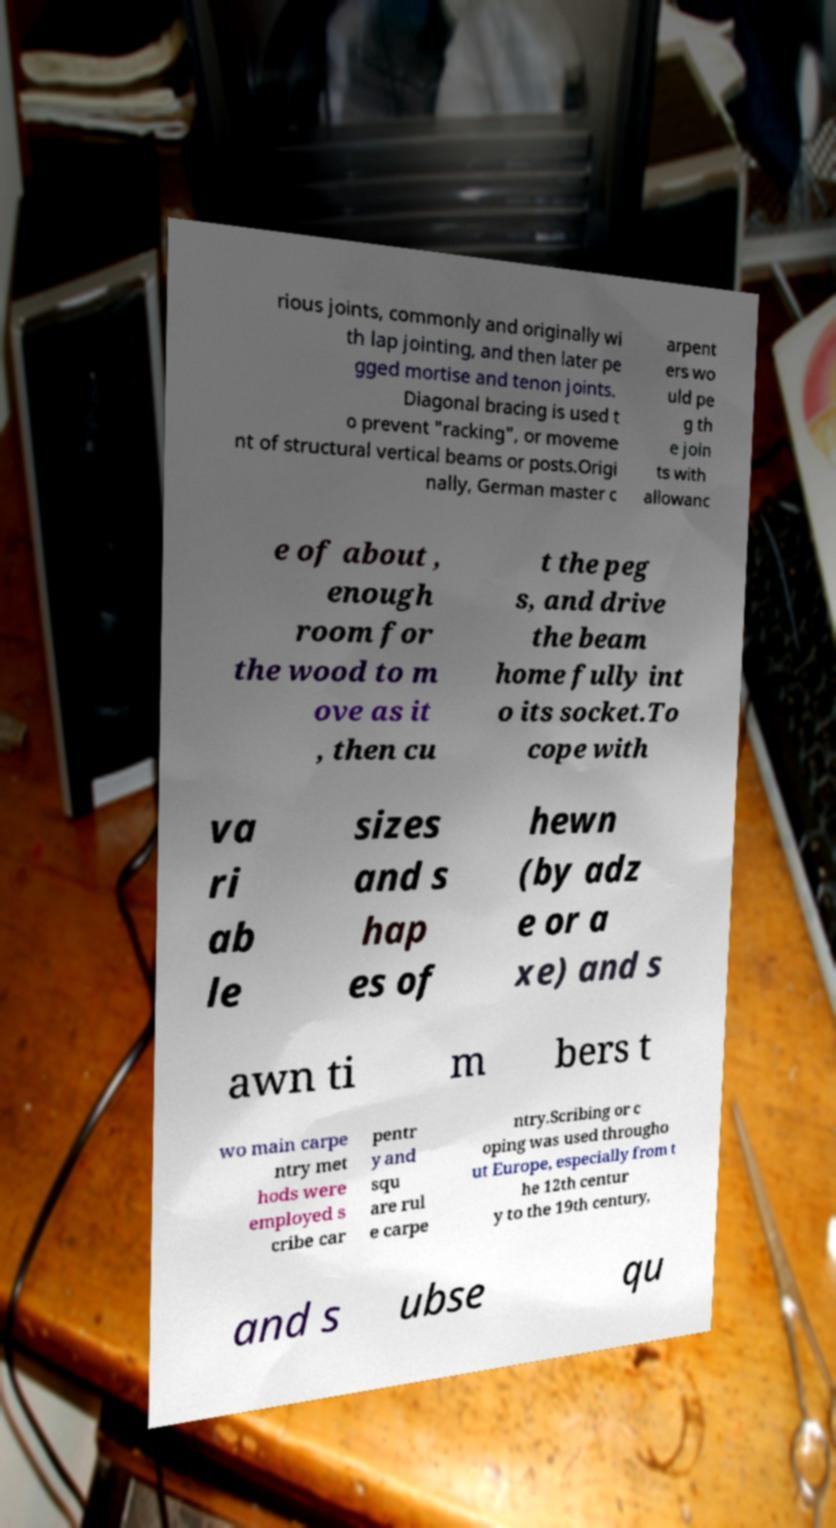Can you read and provide the text displayed in the image?This photo seems to have some interesting text. Can you extract and type it out for me? rious joints, commonly and originally wi th lap jointing, and then later pe gged mortise and tenon joints. Diagonal bracing is used t o prevent "racking", or moveme nt of structural vertical beams or posts.Origi nally, German master c arpent ers wo uld pe g th e join ts with allowanc e of about , enough room for the wood to m ove as it , then cu t the peg s, and drive the beam home fully int o its socket.To cope with va ri ab le sizes and s hap es of hewn (by adz e or a xe) and s awn ti m bers t wo main carpe ntry met hods were employed s cribe car pentr y and squ are rul e carpe ntry.Scribing or c oping was used througho ut Europe, especially from t he 12th centur y to the 19th century, and s ubse qu 